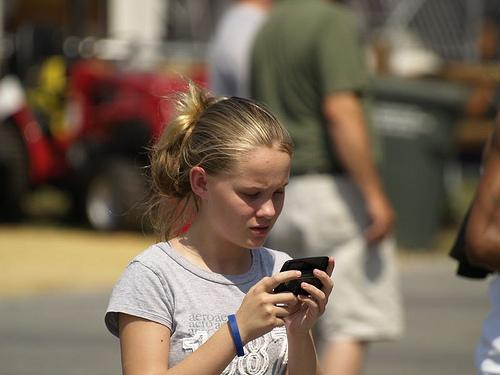Who is looking at their phone in the image? A young woman with blonde hair. What is the color of the phone the young woman is holding? The phone is black. Mention the position of the man with green shirt. The man in the green shirt is standing in the background. What kind of vehicle can be seen in the background? A red truck and a tractor. Provide some details about the girl's shirt and any noticeable features. The girl's shirt is gray, has white lettering, and there is a shadow on it. Describe the man's attire. The man is wearing a green shirt and white shorts. Write down the objects held by the young woman and child. The young woman is holding a black phone, and the child has a blue bracelet on their wrist. Point out some noticeable features of the girl's hairstyle. The girl has blonde and brown hair up in a bun and a clip, with some hair tucked behind her ear. What does the young woman have on her wrist? A blue bracelet. What color is the bracelet on the girl's wrist? Blue What is the main activity of the girl in the image? Texting on her phone Which clothing item does the child in the background wear? White t-shirt What object is the girl holding in her hands? A black cellphone Describe the position of the blue bracelet. On the wrist of the girl holding a phone Is there a man wearing white shorts on the street? Yes What color is the girl's shirt? Gray Which writing can be seen on the girl's shirt?  White lettering In the image, is there any construction equipment visible? Yes, a tractor in the background What is the hairstyle of the girl in the image? Blonde hair up in a clip Does the girl have a red bracelet on her wrist? The girl is actually wearing a blue bracelet on her wrist, not a red one. This instruction might mislead someone to think that the girl is wearing more than one accessory or bracelets of different colors. Describe the girl's expression while she is on her phone. Concerned Where is the blue bracelet located? On the girl's wrist Is the man in the background wearing a blue shirt? The man in the background is actually wearing a green shirt, not blue. This instruction might mislead someone to think that there is another man with a blue shirt. Can you see the girl's hair is in a ponytail? The girl's hair is mentioned as being in a bun or up with a clip, not in a ponytail. This instruction makes the reader believe the girl has a different hairstyle. What type of vehicle can be spotted in the background? Red truck What is the main object of focus in the image? Young woman texting on her phone Identify the man's attire in the image. Green shirt and khaki shorts Does the man in the green shirt have a hat on? There is no mention of the man with the green shirt wearing a hat, so this instruction might create uncertainty for the reader if they are searching for a non-existent hat. What kind of vehicle can you see behind the girl? A red truck List the colors visible in the girl's hair. Blonde and brown Is there a green vehicle in the background? The instructions mention a red vehicle and a tractor in the background, but no green vehicle. This instruction might confuse someone into thinking there is an additional vehicle they need to look for. Identify the color of the shirt worn by a man standing in the background. Green Can you see an animal in the image? There is no mention of any animals in the image, only people and objects. This instruction might confuse someone into thinking there is an animal present that they need to find. What is unique about the girl's right arm? Birthmark 